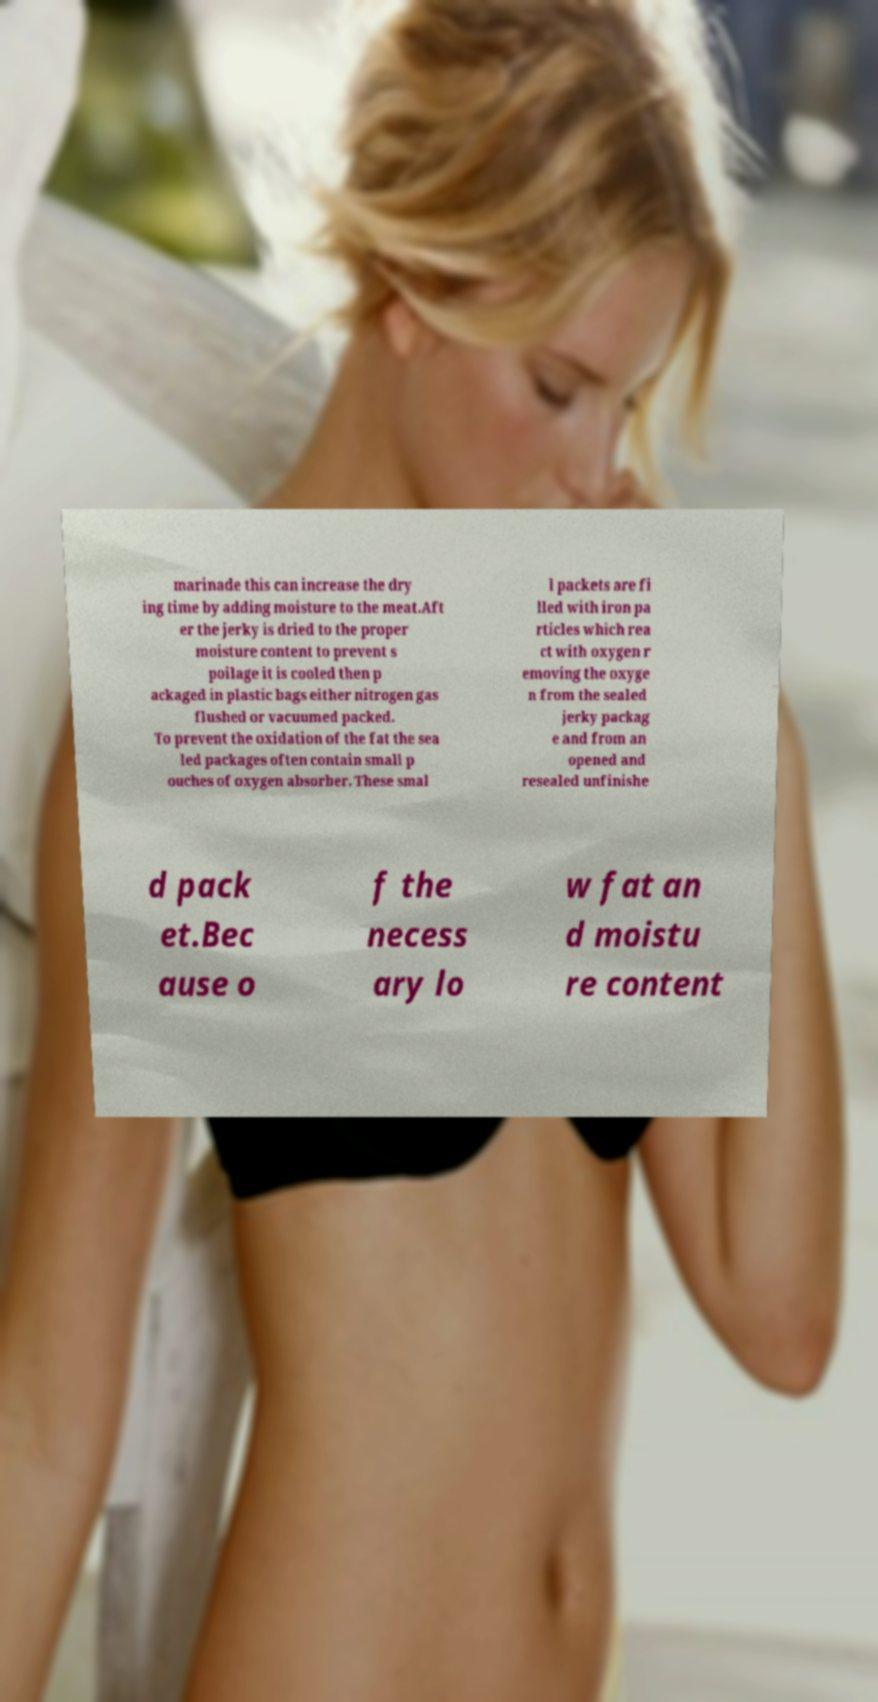Can you accurately transcribe the text from the provided image for me? marinade this can increase the dry ing time by adding moisture to the meat.Aft er the jerky is dried to the proper moisture content to prevent s poilage it is cooled then p ackaged in plastic bags either nitrogen gas flushed or vacuumed packed. To prevent the oxidation of the fat the sea led packages often contain small p ouches of oxygen absorber. These smal l packets are fi lled with iron pa rticles which rea ct with oxygen r emoving the oxyge n from the sealed jerky packag e and from an opened and resealed unfinishe d pack et.Bec ause o f the necess ary lo w fat an d moistu re content 